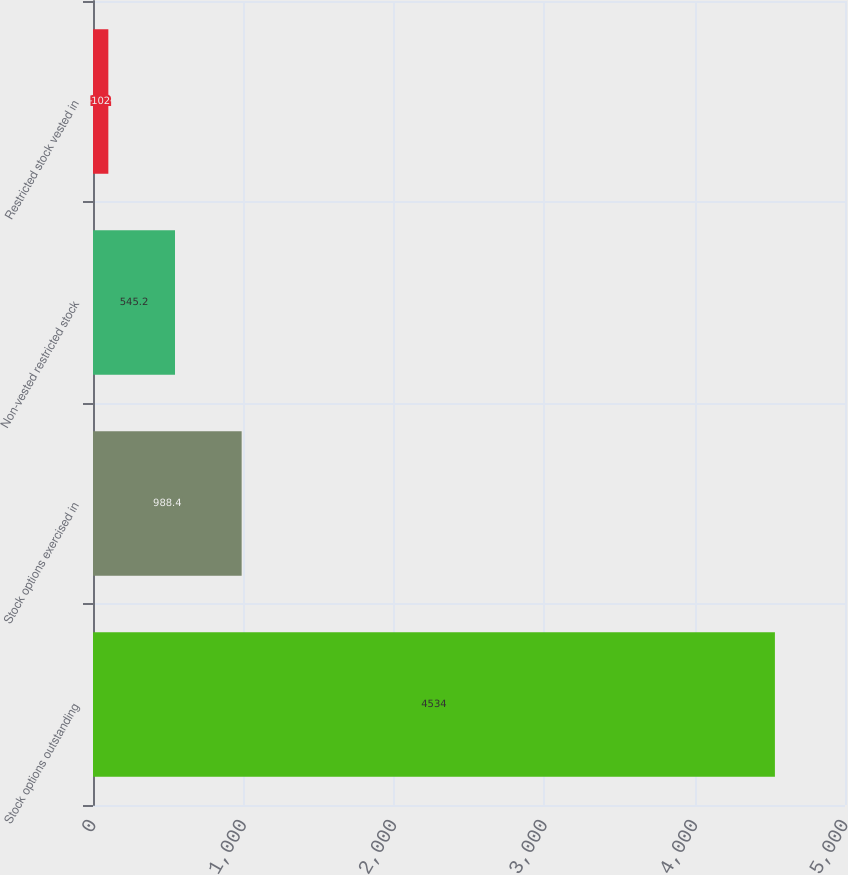Convert chart. <chart><loc_0><loc_0><loc_500><loc_500><bar_chart><fcel>Stock options outstanding<fcel>Stock options exercised in<fcel>Non-vested restricted stock<fcel>Restricted stock vested in<nl><fcel>4534<fcel>988.4<fcel>545.2<fcel>102<nl></chart> 